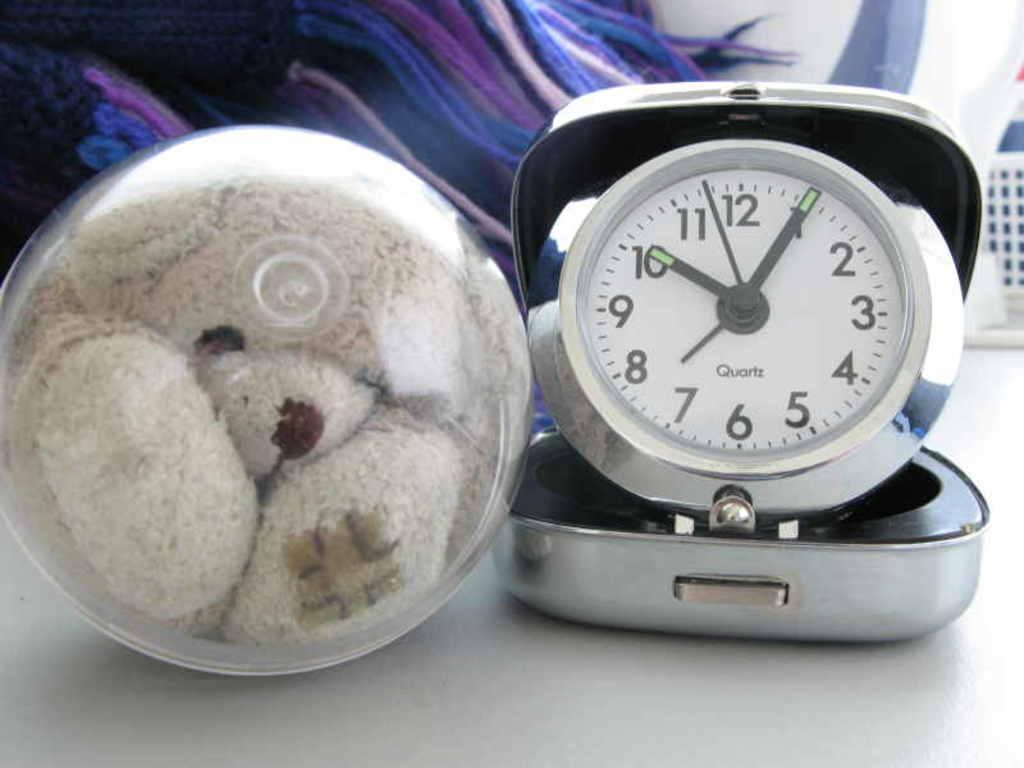<image>
Render a clear and concise summary of the photo. A white round table clock made by Quartz 